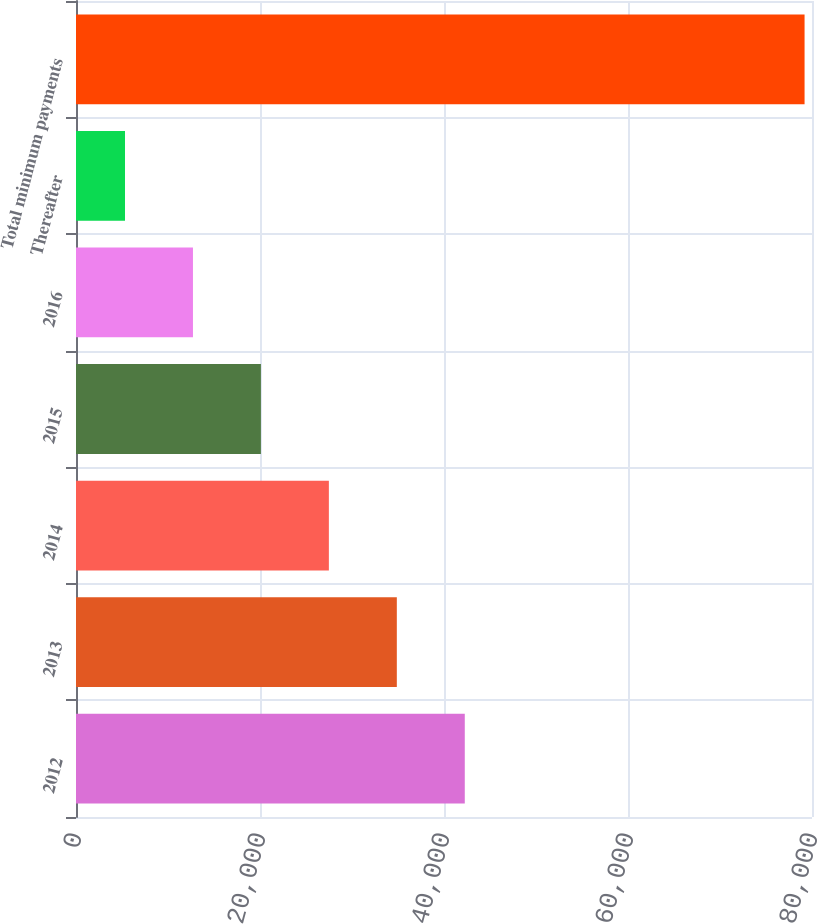Convert chart to OTSL. <chart><loc_0><loc_0><loc_500><loc_500><bar_chart><fcel>2012<fcel>2013<fcel>2014<fcel>2015<fcel>2016<fcel>Thereafter<fcel>Total minimum payments<nl><fcel>42259<fcel>34872.4<fcel>27485.8<fcel>20099.2<fcel>12712.6<fcel>5326<fcel>79192<nl></chart> 